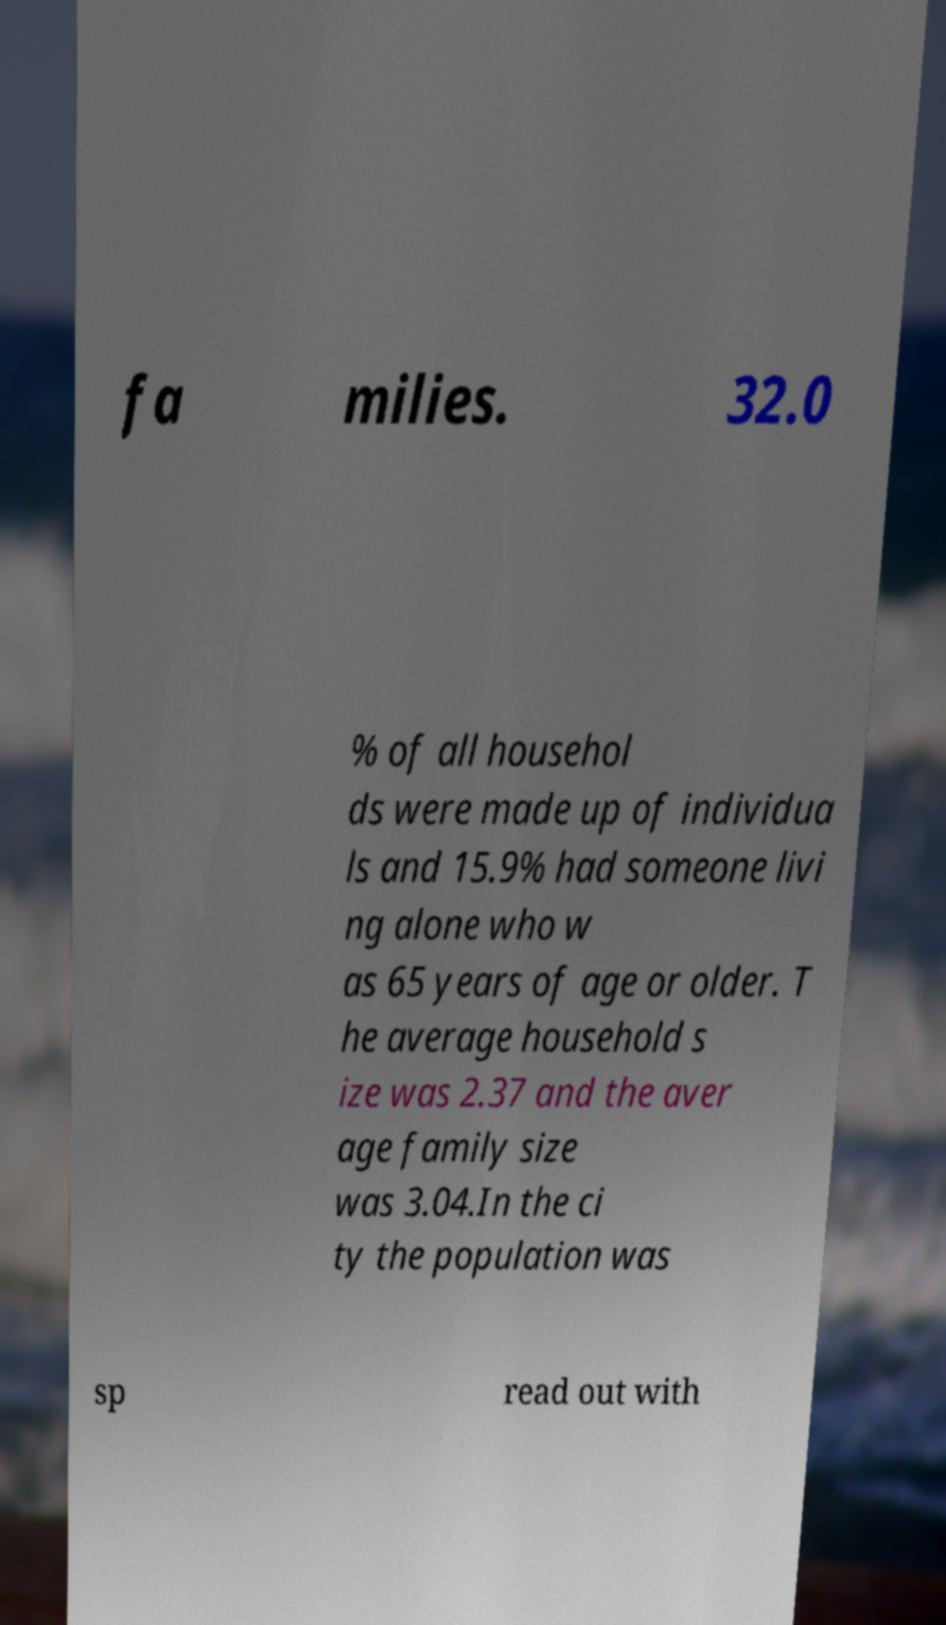Please identify and transcribe the text found in this image. fa milies. 32.0 % of all househol ds were made up of individua ls and 15.9% had someone livi ng alone who w as 65 years of age or older. T he average household s ize was 2.37 and the aver age family size was 3.04.In the ci ty the population was sp read out with 